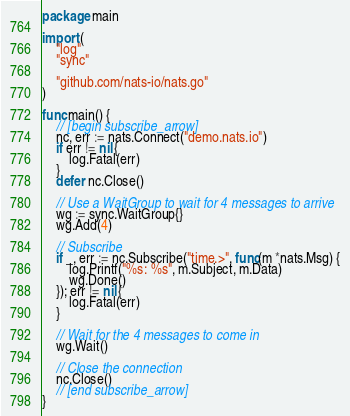Convert code to text. <code><loc_0><loc_0><loc_500><loc_500><_Go_>package main

import (
	"log"
	"sync"

	"github.com/nats-io/nats.go"
)

func main() {
	// [begin subscribe_arrow]
	nc, err := nats.Connect("demo.nats.io")
	if err != nil {
		log.Fatal(err)
	}
	defer nc.Close()

	// Use a WaitGroup to wait for 4 messages to arrive
	wg := sync.WaitGroup{}
	wg.Add(4)

	// Subscribe
	if _, err := nc.Subscribe("time.>", func(m *nats.Msg) {
		log.Printf("%s: %s", m.Subject, m.Data)
		wg.Done()
	}); err != nil {
		log.Fatal(err)
	}

	// Wait for the 4 messages to come in
	wg.Wait()

	// Close the connection
	nc.Close()
	// [end subscribe_arrow]
}
</code> 